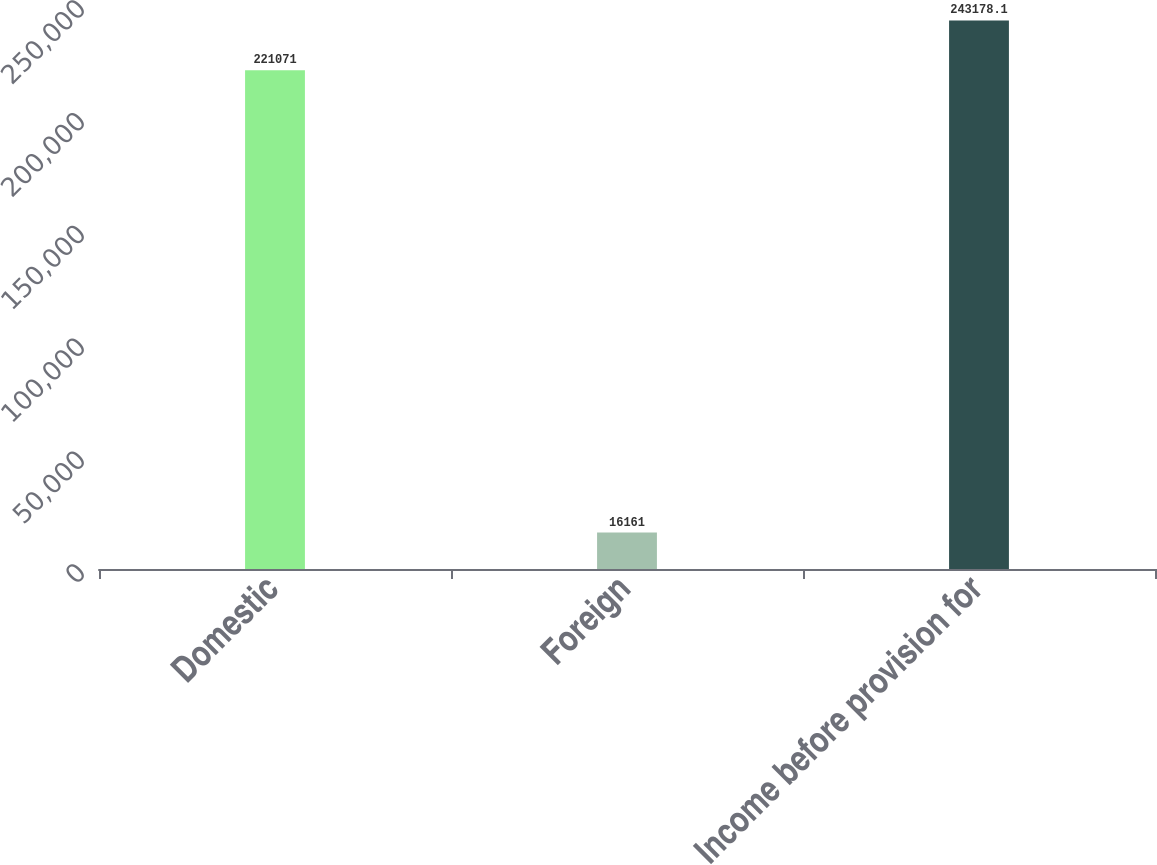Convert chart to OTSL. <chart><loc_0><loc_0><loc_500><loc_500><bar_chart><fcel>Domestic<fcel>Foreign<fcel>Income before provision for<nl><fcel>221071<fcel>16161<fcel>243178<nl></chart> 